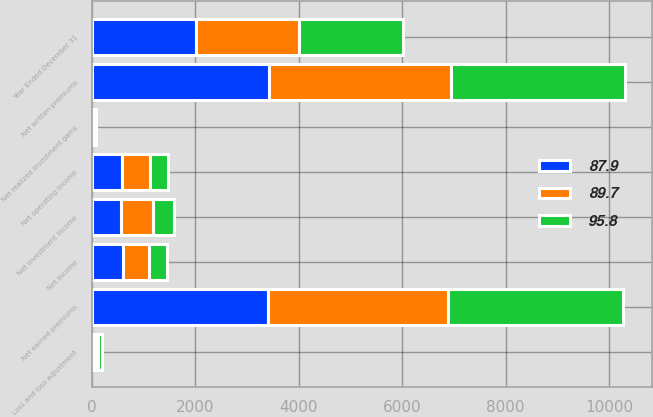Convert chart. <chart><loc_0><loc_0><loc_500><loc_500><stacked_bar_chart><ecel><fcel>Year Ended December 31<fcel>Net written premiums<fcel>Net earned premiums<fcel>Net investment income<fcel>Net operating income<fcel>Net realized investment gains<fcel>Net income<fcel>Loss and loss adjustment<nl><fcel>89.7<fcel>2007<fcel>3506<fcel>3484<fcel>621<fcel>550<fcel>47<fcel>503<fcel>62.8<nl><fcel>87.9<fcel>2006<fcel>3431<fcel>3411<fcel>554<fcel>573<fcel>23<fcel>596<fcel>60.4<nl><fcel>95.8<fcel>2005<fcel>3372<fcel>3367<fcel>416<fcel>348<fcel>2<fcel>350<fcel>68.3<nl></chart> 